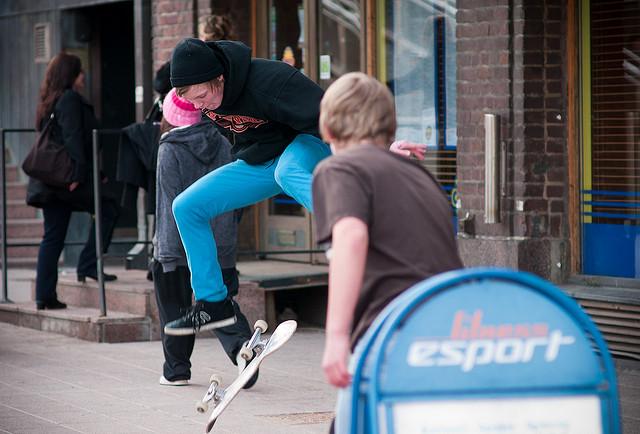What color are the boy's pants?
Be succinct. Blue. What color is the skateboard's wheels?
Keep it brief. White. Are they skating?
Short answer required. Yes. 